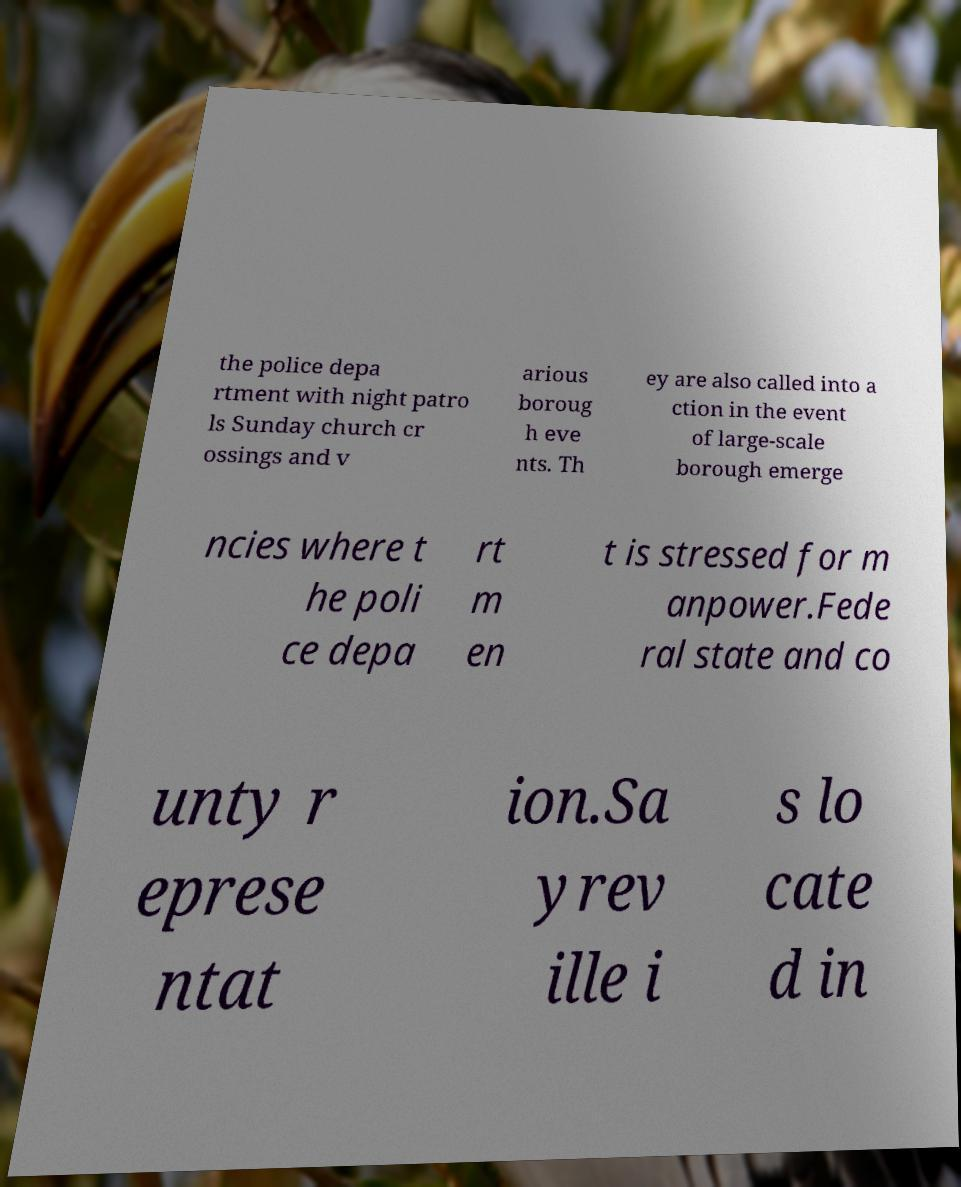Can you read and provide the text displayed in the image?This photo seems to have some interesting text. Can you extract and type it out for me? the police depa rtment with night patro ls Sunday church cr ossings and v arious boroug h eve nts. Th ey are also called into a ction in the event of large-scale borough emerge ncies where t he poli ce depa rt m en t is stressed for m anpower.Fede ral state and co unty r eprese ntat ion.Sa yrev ille i s lo cate d in 